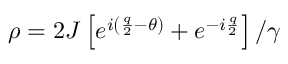<formula> <loc_0><loc_0><loc_500><loc_500>\rho = 2 J \left [ e ^ { i \left ( \frac { q } { 2 } - \theta \right ) } + e ^ { - i \frac { q } { 2 } } \right ] / \gamma</formula> 